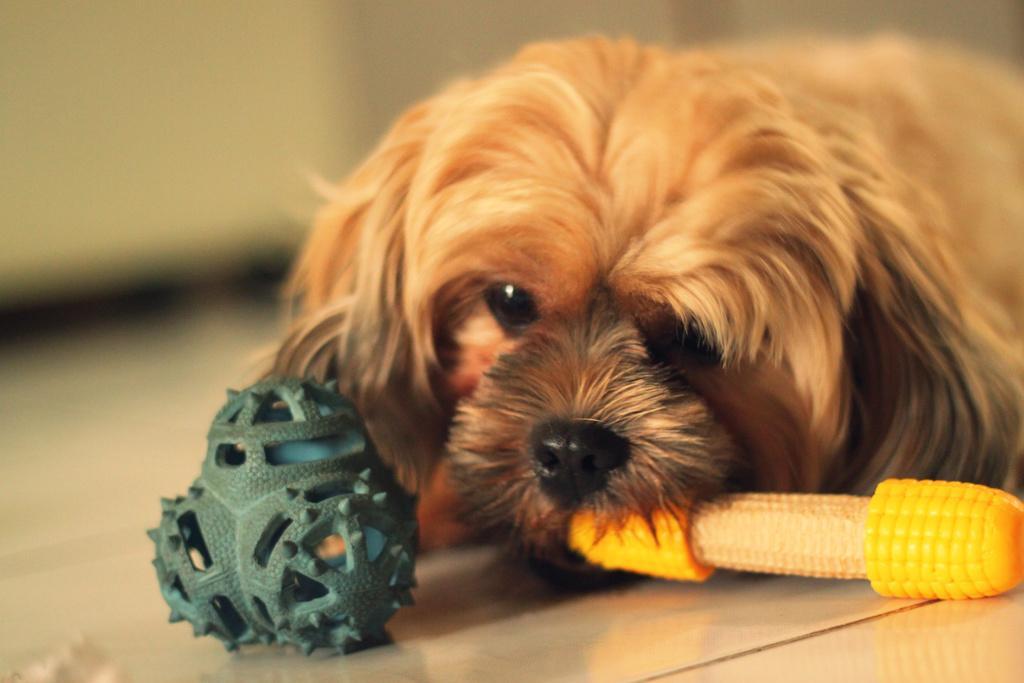In one or two sentences, can you explain what this image depicts? As we can see in the image there is a brown color dog and corn. the background is blurred. 